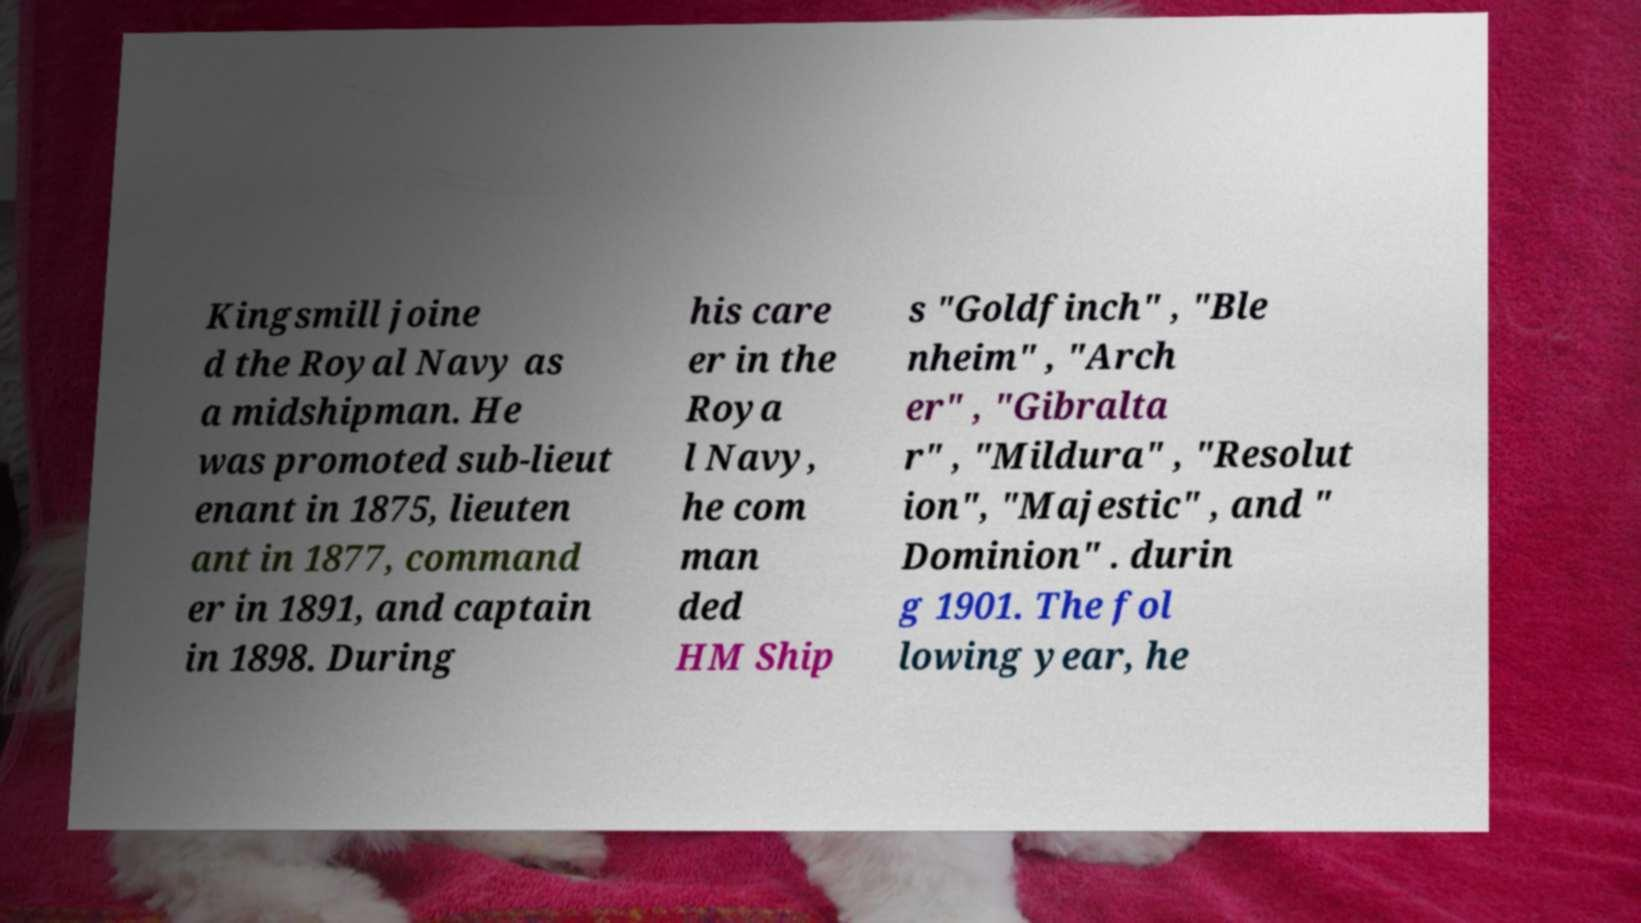What messages or text are displayed in this image? I need them in a readable, typed format. Kingsmill joine d the Royal Navy as a midshipman. He was promoted sub-lieut enant in 1875, lieuten ant in 1877, command er in 1891, and captain in 1898. During his care er in the Roya l Navy, he com man ded HM Ship s "Goldfinch" , "Ble nheim" , "Arch er" , "Gibralta r" , "Mildura" , "Resolut ion", "Majestic" , and " Dominion" . durin g 1901. The fol lowing year, he 